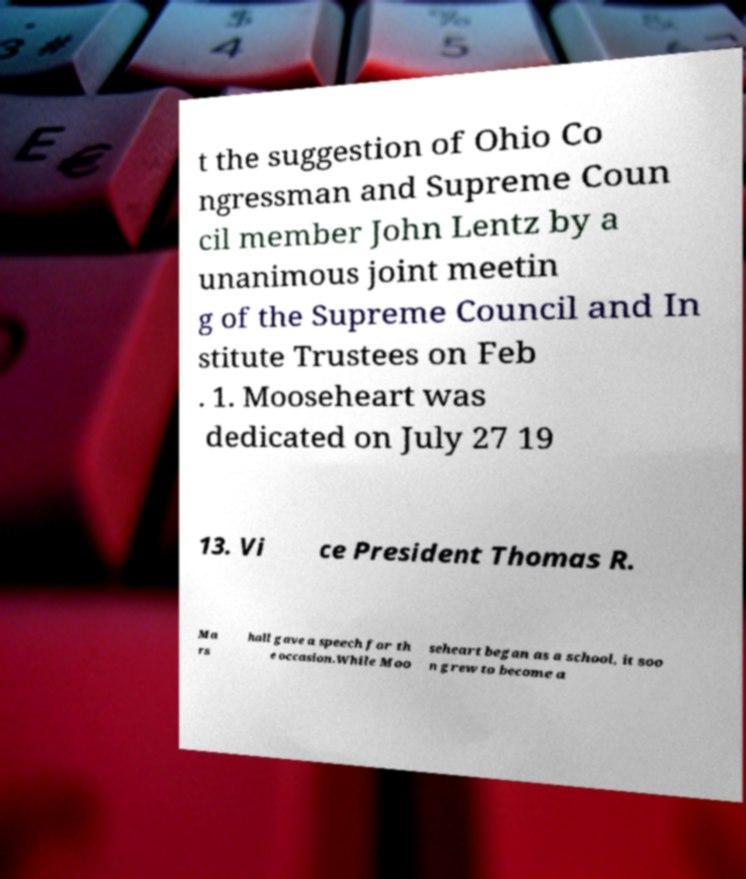Please identify and transcribe the text found in this image. t the suggestion of Ohio Co ngressman and Supreme Coun cil member John Lentz by a unanimous joint meetin g of the Supreme Council and In stitute Trustees on Feb . 1. Mooseheart was dedicated on July 27 19 13. Vi ce President Thomas R. Ma rs hall gave a speech for th e occasion.While Moo seheart began as a school, it soo n grew to become a 